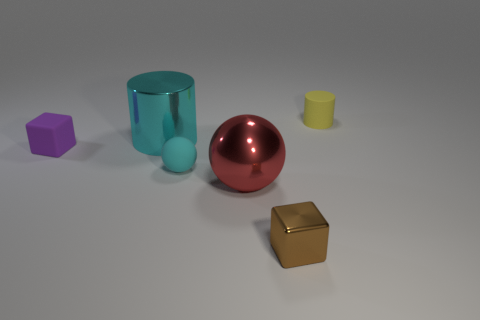Add 1 large metallic things. How many objects exist? 7 Subtract 0 purple cylinders. How many objects are left? 6 Subtract all cylinders. How many objects are left? 4 Subtract all brown things. Subtract all big cylinders. How many objects are left? 4 Add 4 shiny balls. How many shiny balls are left? 5 Add 4 cyan metal cylinders. How many cyan metal cylinders exist? 5 